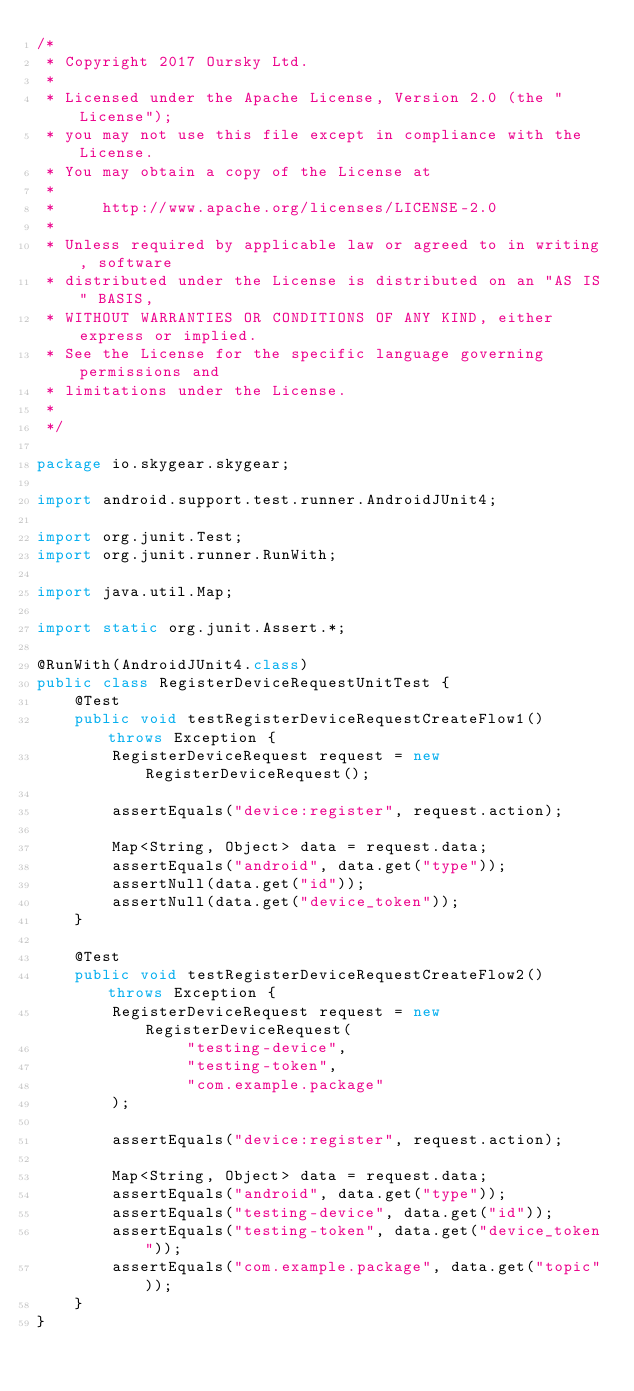<code> <loc_0><loc_0><loc_500><loc_500><_Java_>/*
 * Copyright 2017 Oursky Ltd.
 *
 * Licensed under the Apache License, Version 2.0 (the "License");
 * you may not use this file except in compliance with the License.
 * You may obtain a copy of the License at
 *
 *     http://www.apache.org/licenses/LICENSE-2.0
 *
 * Unless required by applicable law or agreed to in writing, software
 * distributed under the License is distributed on an "AS IS" BASIS,
 * WITHOUT WARRANTIES OR CONDITIONS OF ANY KIND, either express or implied.
 * See the License for the specific language governing permissions and
 * limitations under the License.
 *
 */

package io.skygear.skygear;

import android.support.test.runner.AndroidJUnit4;

import org.junit.Test;
import org.junit.runner.RunWith;

import java.util.Map;

import static org.junit.Assert.*;

@RunWith(AndroidJUnit4.class)
public class RegisterDeviceRequestUnitTest {
    @Test
    public void testRegisterDeviceRequestCreateFlow1() throws Exception {
        RegisterDeviceRequest request = new RegisterDeviceRequest();

        assertEquals("device:register", request.action);

        Map<String, Object> data = request.data;
        assertEquals("android", data.get("type"));
        assertNull(data.get("id"));
        assertNull(data.get("device_token"));
    }

    @Test
    public void testRegisterDeviceRequestCreateFlow2() throws Exception {
        RegisterDeviceRequest request = new RegisterDeviceRequest(
                "testing-device",
                "testing-token",
                "com.example.package"
        );

        assertEquals("device:register", request.action);

        Map<String, Object> data = request.data;
        assertEquals("android", data.get("type"));
        assertEquals("testing-device", data.get("id"));
        assertEquals("testing-token", data.get("device_token"));
        assertEquals("com.example.package", data.get("topic"));
    }
}</code> 